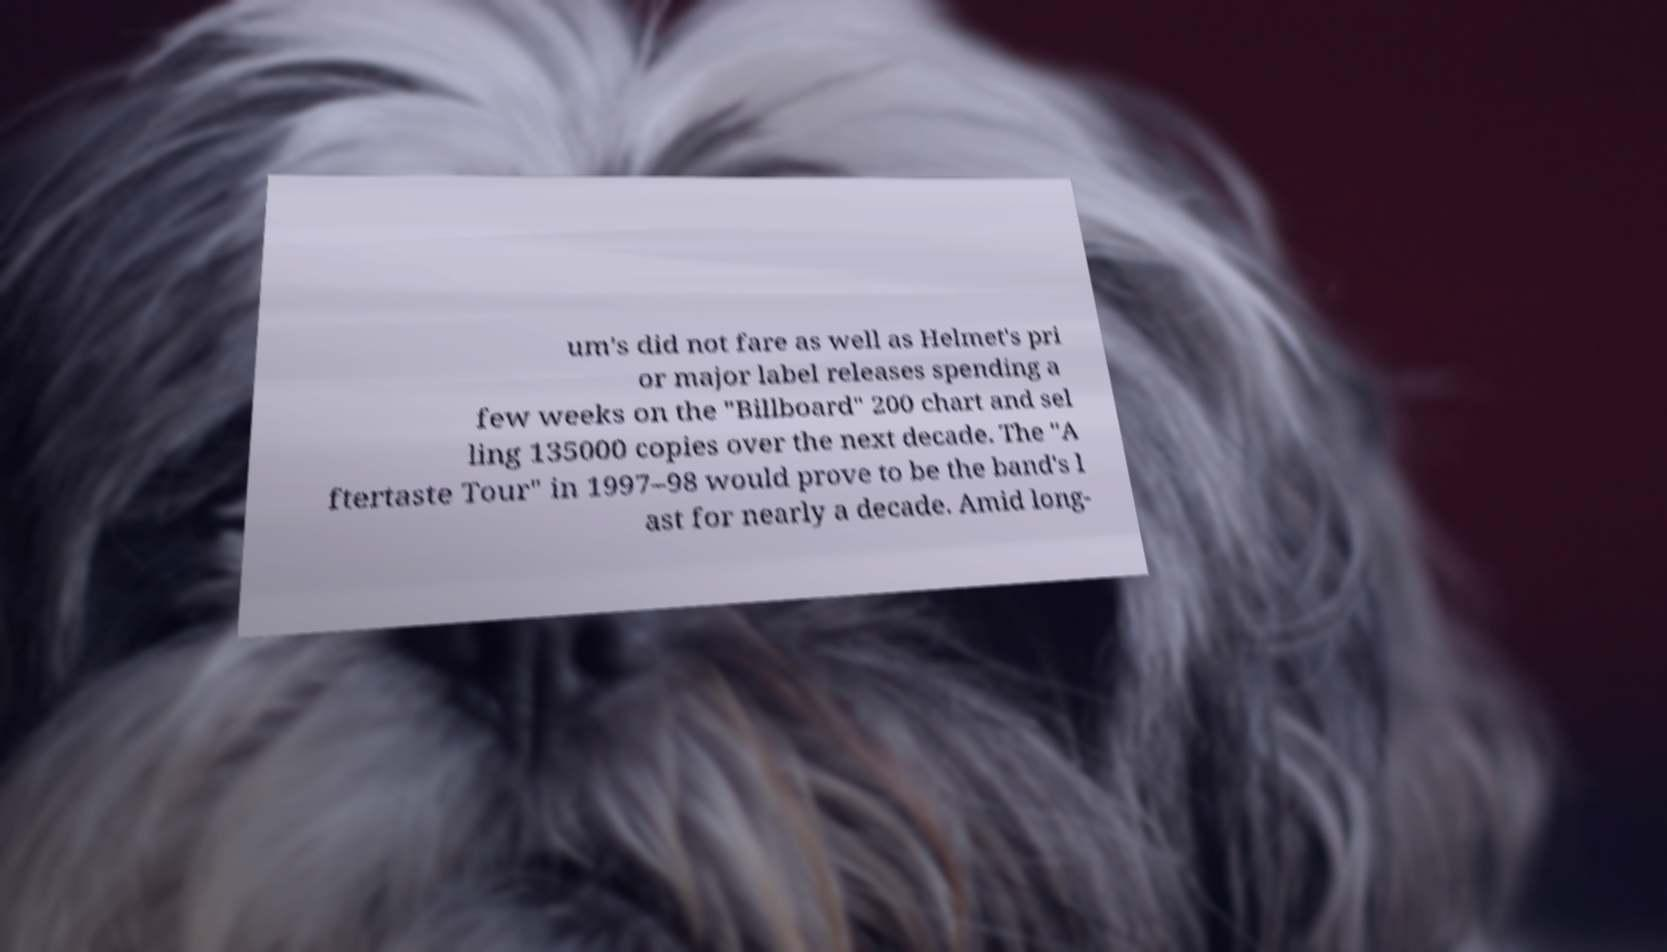Please read and relay the text visible in this image. What does it say? um's did not fare as well as Helmet's pri or major label releases spending a few weeks on the "Billboard" 200 chart and sel ling 135000 copies over the next decade. The "A ftertaste Tour" in 1997–98 would prove to be the band's l ast for nearly a decade. Amid long- 